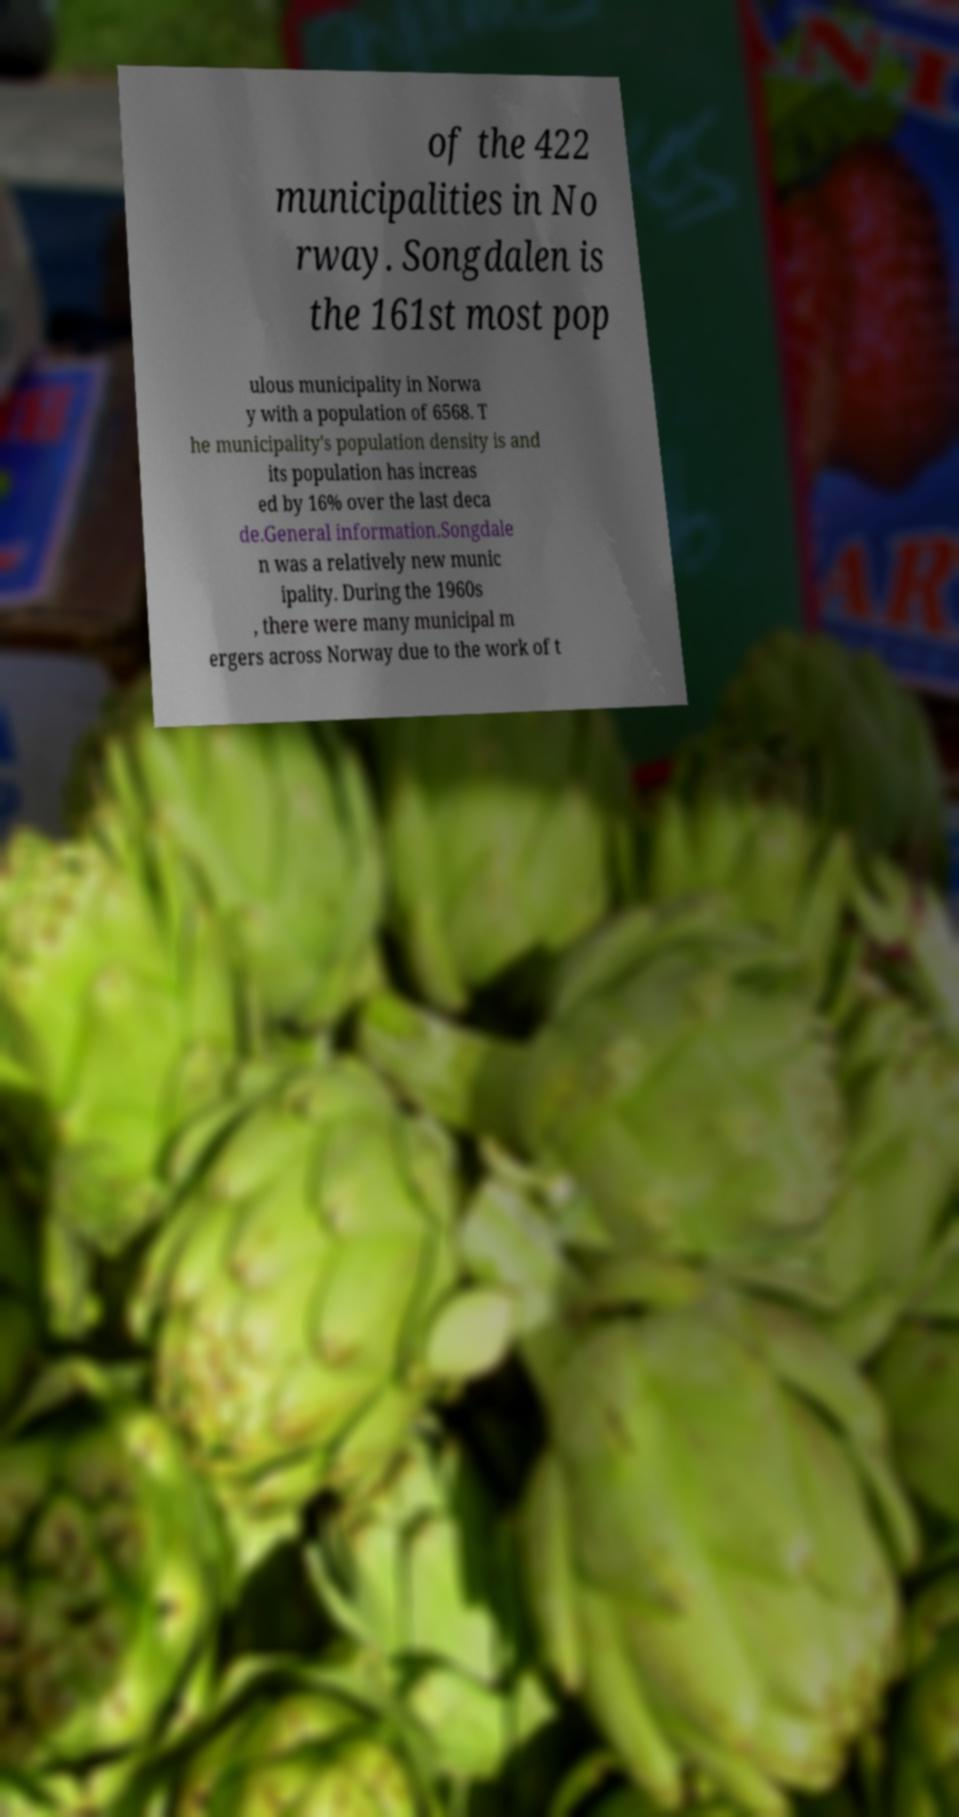Can you accurately transcribe the text from the provided image for me? of the 422 municipalities in No rway. Songdalen is the 161st most pop ulous municipality in Norwa y with a population of 6568. T he municipality's population density is and its population has increas ed by 16% over the last deca de.General information.Songdale n was a relatively new munic ipality. During the 1960s , there were many municipal m ergers across Norway due to the work of t 